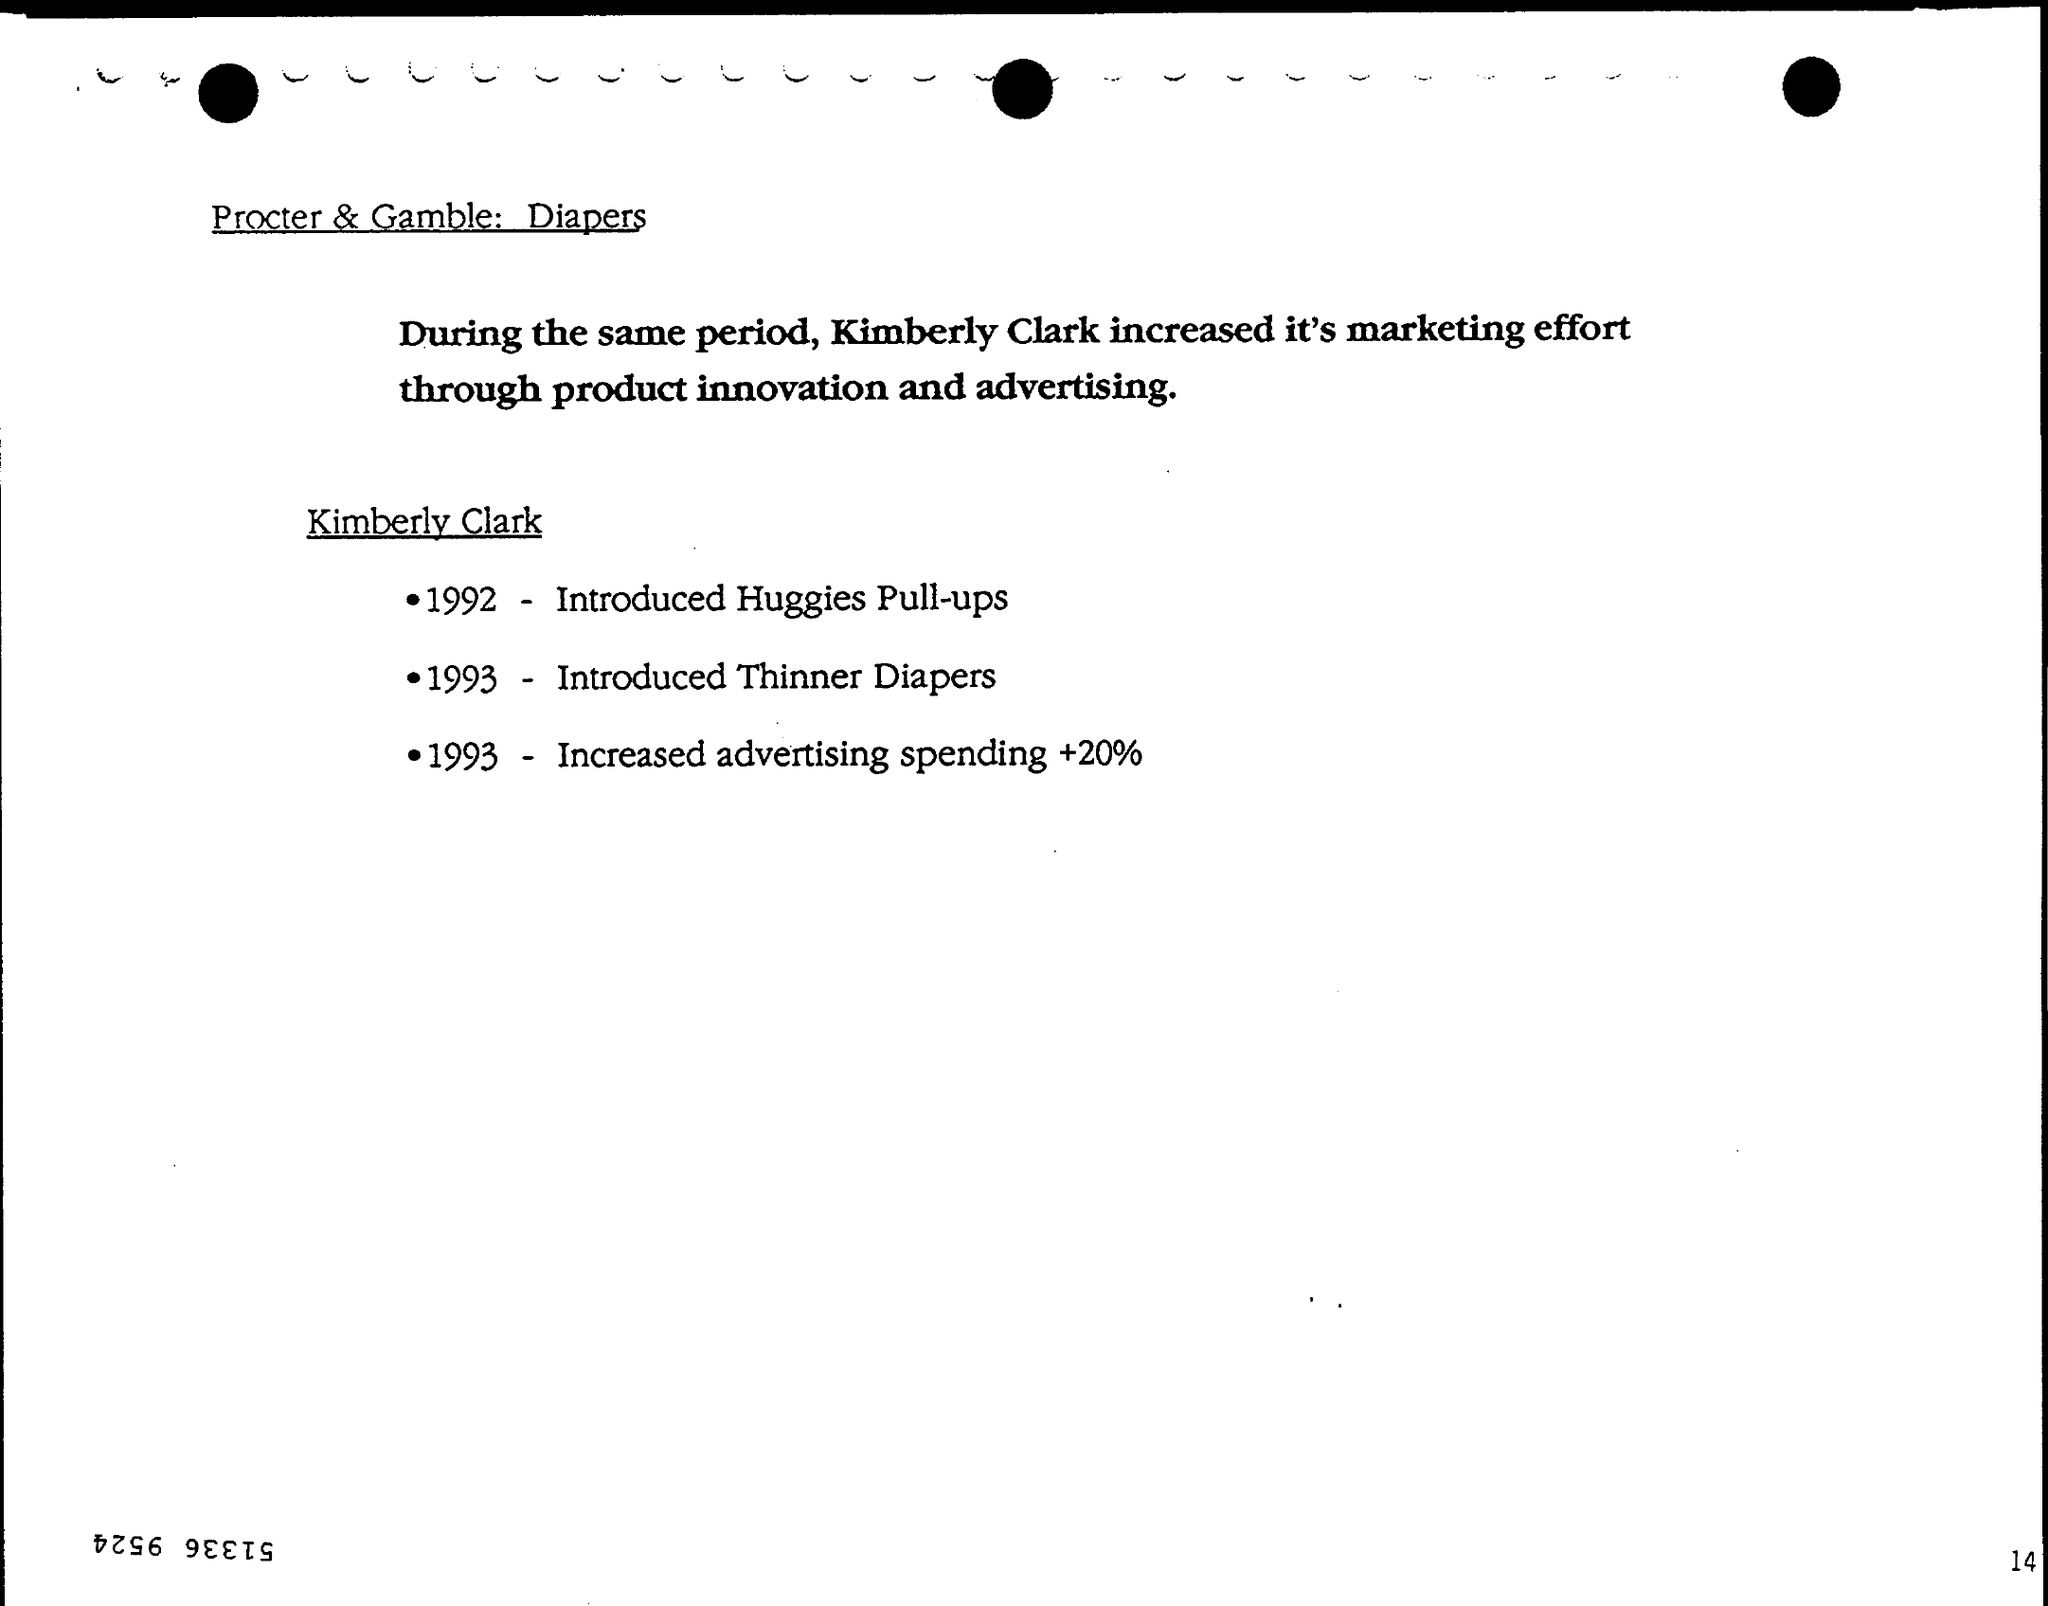Outline some significant characteristics in this image. Huggies Pull-ups were introduced in 1992. Thinner diapers were introduced in 1993. Advertising spending increased by 20% in 1993. 